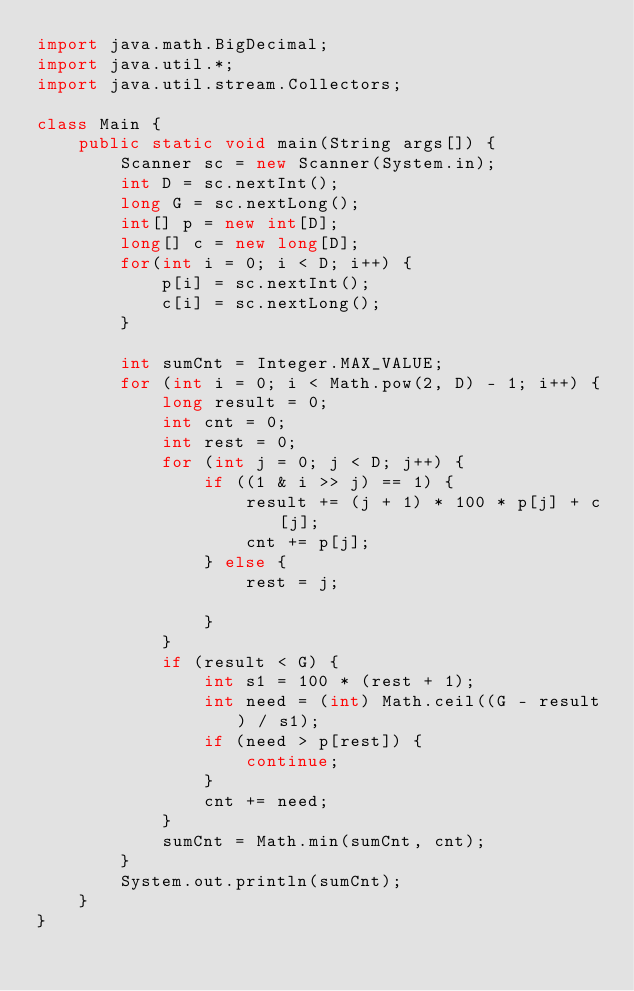Convert code to text. <code><loc_0><loc_0><loc_500><loc_500><_Java_>import java.math.BigDecimal;
import java.util.*;
import java.util.stream.Collectors;

class Main {
    public static void main(String args[]) {
        Scanner sc = new Scanner(System.in);
        int D = sc.nextInt();
        long G = sc.nextLong();
        int[] p = new int[D];
        long[] c = new long[D];
        for(int i = 0; i < D; i++) {
            p[i] = sc.nextInt();
            c[i] = sc.nextLong();
        }

        int sumCnt = Integer.MAX_VALUE;
        for (int i = 0; i < Math.pow(2, D) - 1; i++) {
            long result = 0;
            int cnt = 0;
            int rest = 0;
            for (int j = 0; j < D; j++) {
                if ((1 & i >> j) == 1) {
                    result += (j + 1) * 100 * p[j] + c[j];
                    cnt += p[j];
                } else {
                    rest = j;

                }
            }
            if (result < G) {
                int s1 = 100 * (rest + 1);
                int need = (int) Math.ceil((G - result) / s1);
                if (need > p[rest]) {
                    continue;
                }
                cnt += need;
            }
            sumCnt = Math.min(sumCnt, cnt);
        }
        System.out.println(sumCnt);
    }
}</code> 